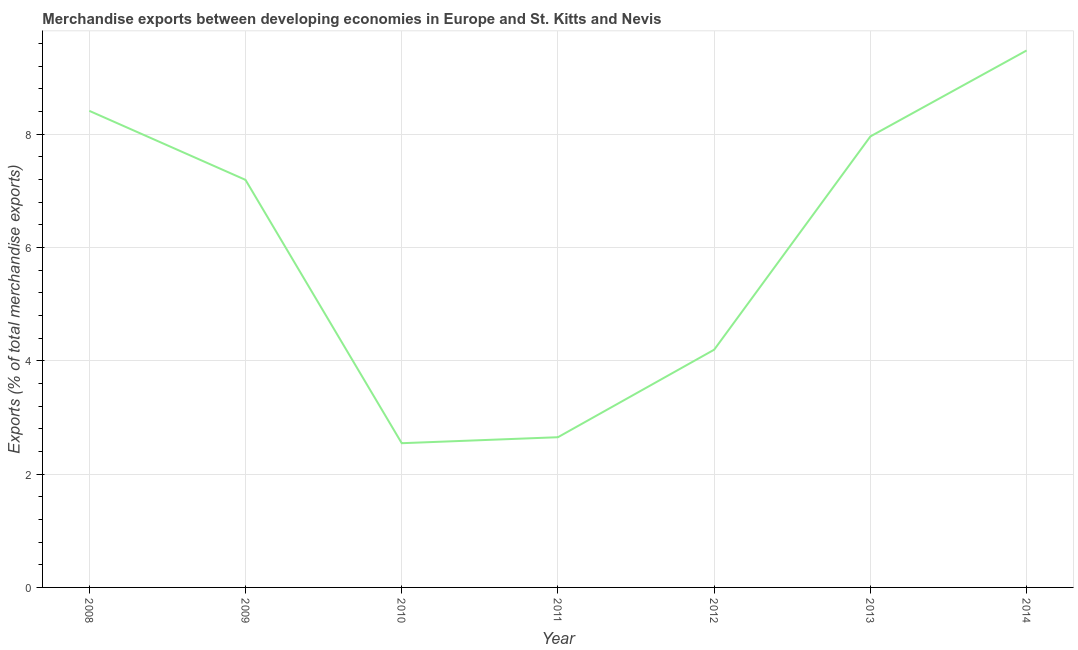What is the merchandise exports in 2012?
Your response must be concise. 4.2. Across all years, what is the maximum merchandise exports?
Provide a short and direct response. 9.48. Across all years, what is the minimum merchandise exports?
Offer a terse response. 2.55. What is the sum of the merchandise exports?
Provide a succinct answer. 42.43. What is the difference between the merchandise exports in 2013 and 2014?
Offer a very short reply. -1.52. What is the average merchandise exports per year?
Ensure brevity in your answer.  6.06. What is the median merchandise exports?
Keep it short and to the point. 7.19. What is the ratio of the merchandise exports in 2009 to that in 2012?
Your answer should be very brief. 1.71. What is the difference between the highest and the second highest merchandise exports?
Provide a succinct answer. 1.07. Is the sum of the merchandise exports in 2013 and 2014 greater than the maximum merchandise exports across all years?
Offer a very short reply. Yes. What is the difference between the highest and the lowest merchandise exports?
Make the answer very short. 6.93. Does the merchandise exports monotonically increase over the years?
Keep it short and to the point. No. How many years are there in the graph?
Provide a succinct answer. 7. What is the difference between two consecutive major ticks on the Y-axis?
Your response must be concise. 2. Are the values on the major ticks of Y-axis written in scientific E-notation?
Provide a short and direct response. No. Does the graph contain any zero values?
Your answer should be very brief. No. Does the graph contain grids?
Ensure brevity in your answer.  Yes. What is the title of the graph?
Give a very brief answer. Merchandise exports between developing economies in Europe and St. Kitts and Nevis. What is the label or title of the Y-axis?
Provide a short and direct response. Exports (% of total merchandise exports). What is the Exports (% of total merchandise exports) of 2008?
Your answer should be compact. 8.41. What is the Exports (% of total merchandise exports) in 2009?
Give a very brief answer. 7.19. What is the Exports (% of total merchandise exports) of 2010?
Your response must be concise. 2.55. What is the Exports (% of total merchandise exports) of 2011?
Keep it short and to the point. 2.65. What is the Exports (% of total merchandise exports) of 2012?
Your response must be concise. 4.2. What is the Exports (% of total merchandise exports) of 2013?
Make the answer very short. 7.96. What is the Exports (% of total merchandise exports) in 2014?
Keep it short and to the point. 9.48. What is the difference between the Exports (% of total merchandise exports) in 2008 and 2009?
Give a very brief answer. 1.22. What is the difference between the Exports (% of total merchandise exports) in 2008 and 2010?
Make the answer very short. 5.87. What is the difference between the Exports (% of total merchandise exports) in 2008 and 2011?
Provide a succinct answer. 5.76. What is the difference between the Exports (% of total merchandise exports) in 2008 and 2012?
Provide a short and direct response. 4.22. What is the difference between the Exports (% of total merchandise exports) in 2008 and 2013?
Offer a terse response. 0.45. What is the difference between the Exports (% of total merchandise exports) in 2008 and 2014?
Offer a terse response. -1.07. What is the difference between the Exports (% of total merchandise exports) in 2009 and 2010?
Keep it short and to the point. 4.65. What is the difference between the Exports (% of total merchandise exports) in 2009 and 2011?
Give a very brief answer. 4.54. What is the difference between the Exports (% of total merchandise exports) in 2009 and 2012?
Ensure brevity in your answer.  3. What is the difference between the Exports (% of total merchandise exports) in 2009 and 2013?
Provide a short and direct response. -0.77. What is the difference between the Exports (% of total merchandise exports) in 2009 and 2014?
Keep it short and to the point. -2.28. What is the difference between the Exports (% of total merchandise exports) in 2010 and 2011?
Give a very brief answer. -0.11. What is the difference between the Exports (% of total merchandise exports) in 2010 and 2012?
Your answer should be compact. -1.65. What is the difference between the Exports (% of total merchandise exports) in 2010 and 2013?
Keep it short and to the point. -5.41. What is the difference between the Exports (% of total merchandise exports) in 2010 and 2014?
Give a very brief answer. -6.93. What is the difference between the Exports (% of total merchandise exports) in 2011 and 2012?
Your response must be concise. -1.54. What is the difference between the Exports (% of total merchandise exports) in 2011 and 2013?
Offer a very short reply. -5.31. What is the difference between the Exports (% of total merchandise exports) in 2011 and 2014?
Offer a terse response. -6.83. What is the difference between the Exports (% of total merchandise exports) in 2012 and 2013?
Offer a terse response. -3.76. What is the difference between the Exports (% of total merchandise exports) in 2012 and 2014?
Ensure brevity in your answer.  -5.28. What is the difference between the Exports (% of total merchandise exports) in 2013 and 2014?
Your answer should be compact. -1.52. What is the ratio of the Exports (% of total merchandise exports) in 2008 to that in 2009?
Make the answer very short. 1.17. What is the ratio of the Exports (% of total merchandise exports) in 2008 to that in 2010?
Give a very brief answer. 3.31. What is the ratio of the Exports (% of total merchandise exports) in 2008 to that in 2011?
Keep it short and to the point. 3.17. What is the ratio of the Exports (% of total merchandise exports) in 2008 to that in 2012?
Make the answer very short. 2. What is the ratio of the Exports (% of total merchandise exports) in 2008 to that in 2013?
Your answer should be very brief. 1.06. What is the ratio of the Exports (% of total merchandise exports) in 2008 to that in 2014?
Keep it short and to the point. 0.89. What is the ratio of the Exports (% of total merchandise exports) in 2009 to that in 2010?
Keep it short and to the point. 2.83. What is the ratio of the Exports (% of total merchandise exports) in 2009 to that in 2011?
Your answer should be compact. 2.71. What is the ratio of the Exports (% of total merchandise exports) in 2009 to that in 2012?
Provide a short and direct response. 1.71. What is the ratio of the Exports (% of total merchandise exports) in 2009 to that in 2013?
Your response must be concise. 0.9. What is the ratio of the Exports (% of total merchandise exports) in 2009 to that in 2014?
Provide a succinct answer. 0.76. What is the ratio of the Exports (% of total merchandise exports) in 2010 to that in 2012?
Give a very brief answer. 0.61. What is the ratio of the Exports (% of total merchandise exports) in 2010 to that in 2013?
Keep it short and to the point. 0.32. What is the ratio of the Exports (% of total merchandise exports) in 2010 to that in 2014?
Provide a succinct answer. 0.27. What is the ratio of the Exports (% of total merchandise exports) in 2011 to that in 2012?
Your answer should be compact. 0.63. What is the ratio of the Exports (% of total merchandise exports) in 2011 to that in 2013?
Your answer should be very brief. 0.33. What is the ratio of the Exports (% of total merchandise exports) in 2011 to that in 2014?
Give a very brief answer. 0.28. What is the ratio of the Exports (% of total merchandise exports) in 2012 to that in 2013?
Keep it short and to the point. 0.53. What is the ratio of the Exports (% of total merchandise exports) in 2012 to that in 2014?
Keep it short and to the point. 0.44. What is the ratio of the Exports (% of total merchandise exports) in 2013 to that in 2014?
Offer a very short reply. 0.84. 